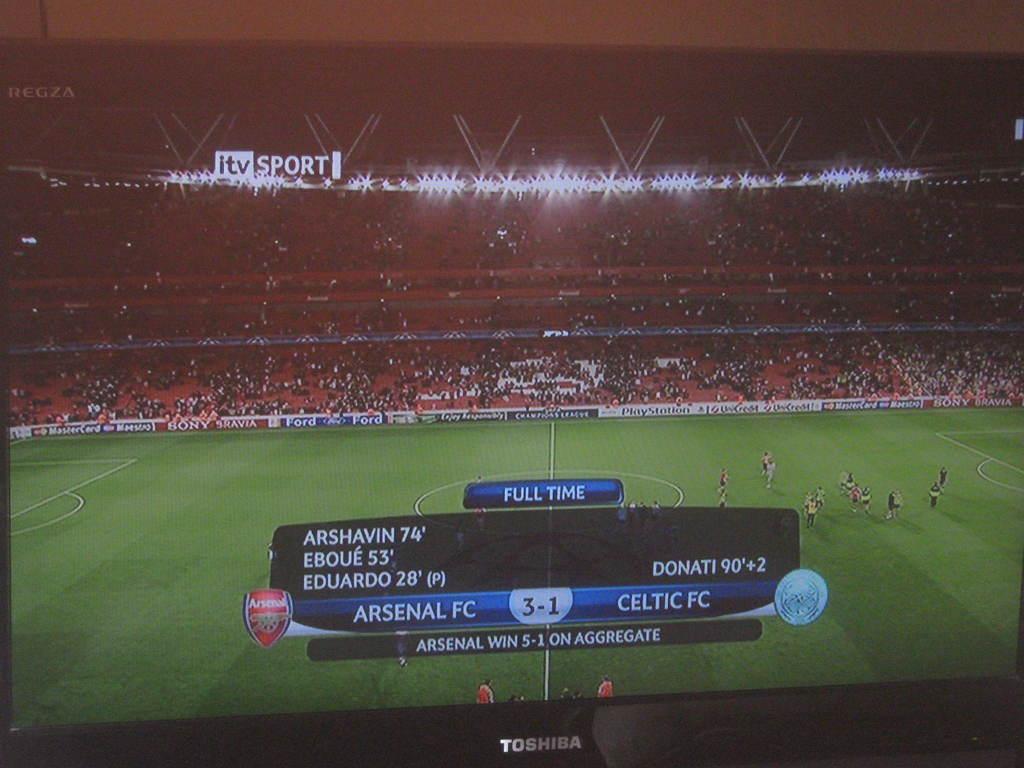How many goals has arsenal fc scored in the game?
Your answer should be compact. 3. What is the name of the station showing the sport?
Give a very brief answer. Itv sport. 